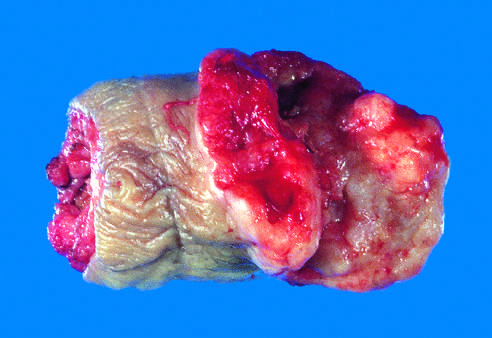what is deformed by an ulcerated, infiltrative mass?
Answer the question using a single word or phrase. The glans penis 